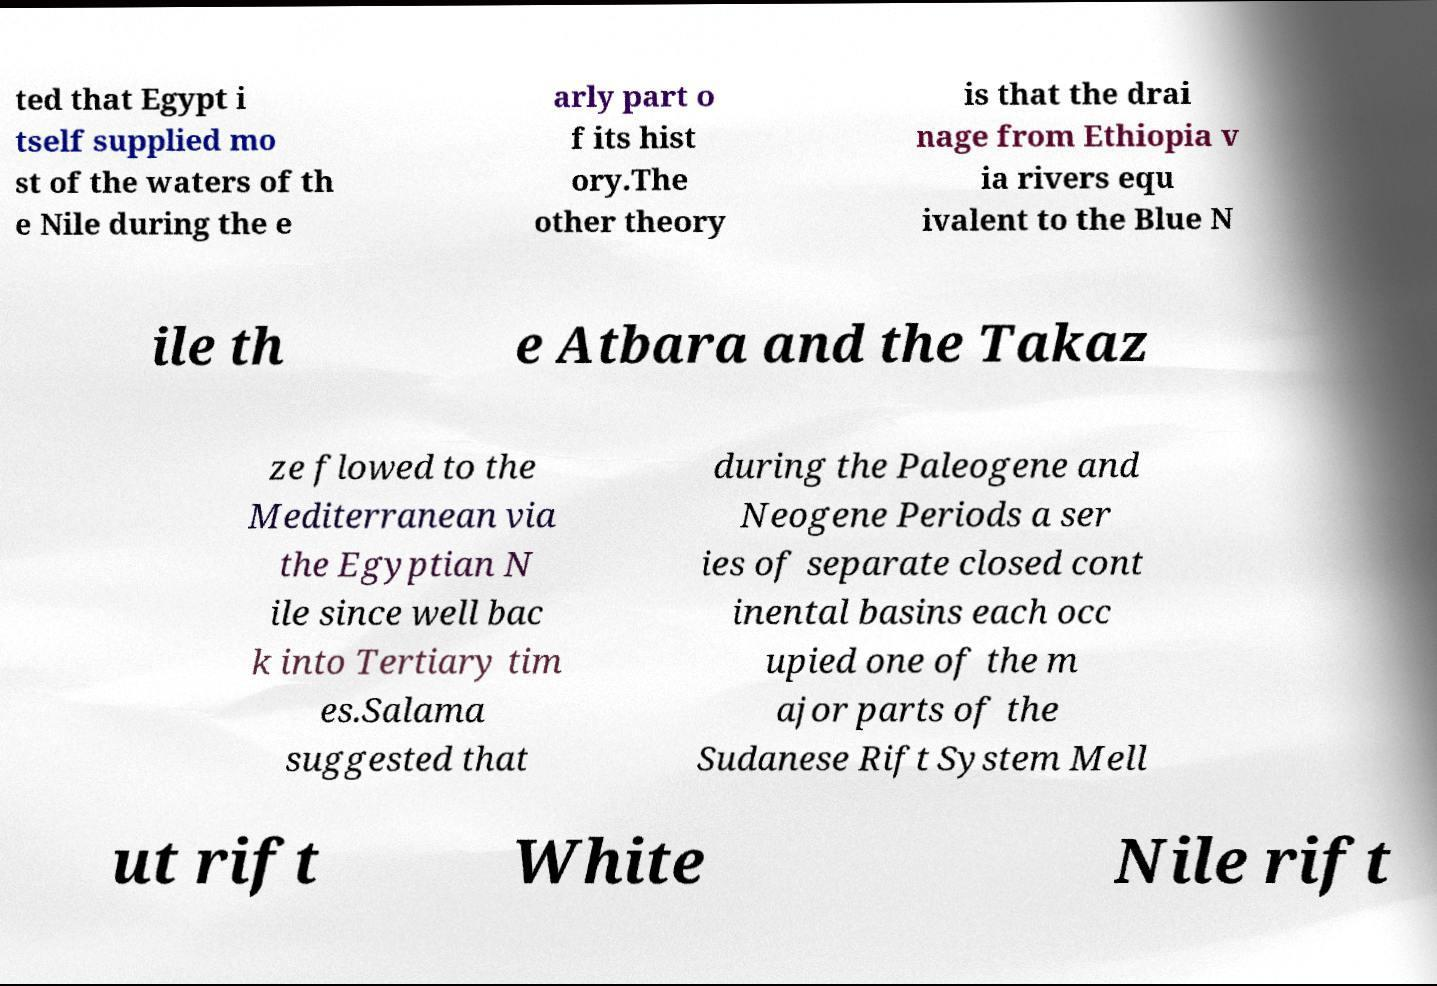Could you assist in decoding the text presented in this image and type it out clearly? ted that Egypt i tself supplied mo st of the waters of th e Nile during the e arly part o f its hist ory.The other theory is that the drai nage from Ethiopia v ia rivers equ ivalent to the Blue N ile th e Atbara and the Takaz ze flowed to the Mediterranean via the Egyptian N ile since well bac k into Tertiary tim es.Salama suggested that during the Paleogene and Neogene Periods a ser ies of separate closed cont inental basins each occ upied one of the m ajor parts of the Sudanese Rift System Mell ut rift White Nile rift 